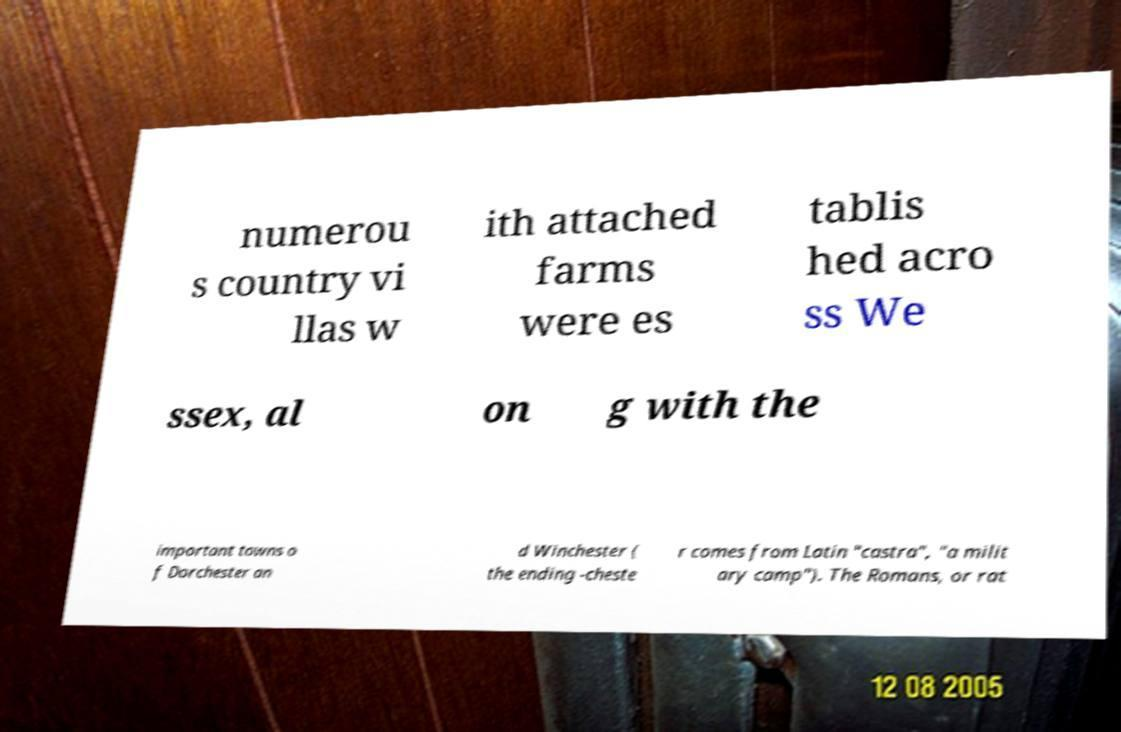There's text embedded in this image that I need extracted. Can you transcribe it verbatim? numerou s country vi llas w ith attached farms were es tablis hed acro ss We ssex, al on g with the important towns o f Dorchester an d Winchester ( the ending -cheste r comes from Latin "castra", "a milit ary camp"). The Romans, or rat 